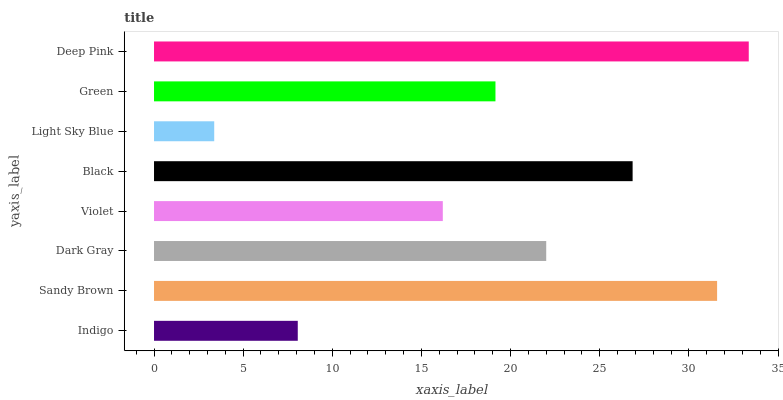Is Light Sky Blue the minimum?
Answer yes or no. Yes. Is Deep Pink the maximum?
Answer yes or no. Yes. Is Sandy Brown the minimum?
Answer yes or no. No. Is Sandy Brown the maximum?
Answer yes or no. No. Is Sandy Brown greater than Indigo?
Answer yes or no. Yes. Is Indigo less than Sandy Brown?
Answer yes or no. Yes. Is Indigo greater than Sandy Brown?
Answer yes or no. No. Is Sandy Brown less than Indigo?
Answer yes or no. No. Is Dark Gray the high median?
Answer yes or no. Yes. Is Green the low median?
Answer yes or no. Yes. Is Light Sky Blue the high median?
Answer yes or no. No. Is Violet the low median?
Answer yes or no. No. 